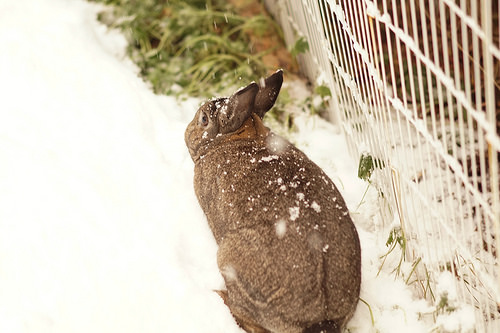<image>
Is there a rabbit on the snow? Yes. Looking at the image, I can see the rabbit is positioned on top of the snow, with the snow providing support. Is the rabbit in the snow? Yes. The rabbit is contained within or inside the snow, showing a containment relationship. Is there a cat in the dirt? No. The cat is not contained within the dirt. These objects have a different spatial relationship. 